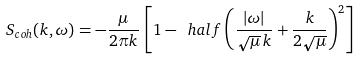<formula> <loc_0><loc_0><loc_500><loc_500>S _ { c o h } ( { k } , \omega ) = - \frac { \mu } { 2 \pi k } \, \left [ 1 - \ h a l f \left ( \frac { | \omega | } { \sqrt { \mu } \, k } + \frac { k } { 2 \sqrt { \mu } } \right ) ^ { 2 } \right ]</formula> 